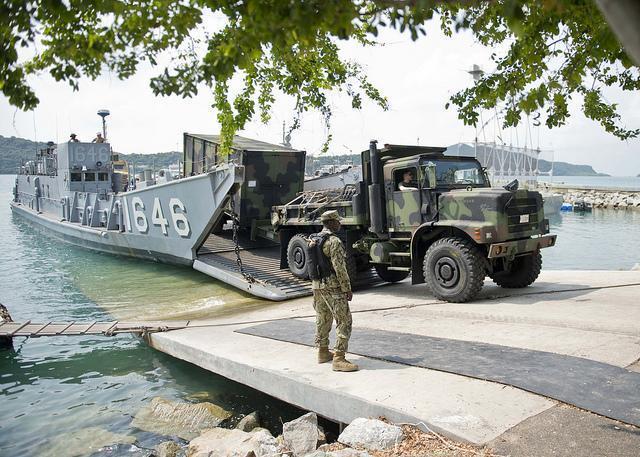How many numbers appear on the side of the ship?
Give a very brief answer. 4. How many wheels are visible?
Give a very brief answer. 3. 